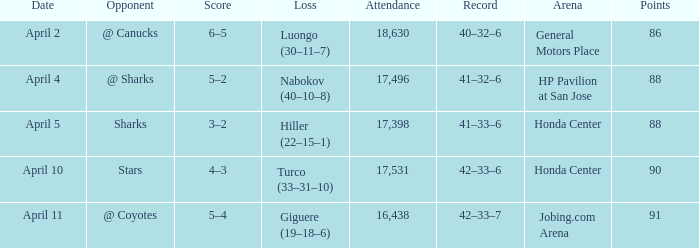Which score has a Loss of hiller (22–15–1)? 3–2. 